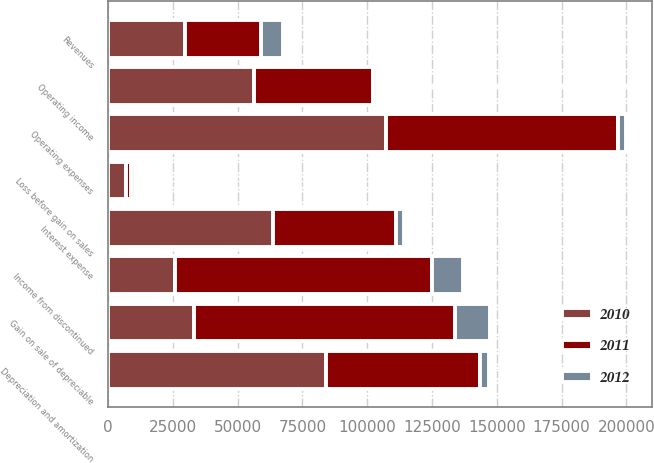<chart> <loc_0><loc_0><loc_500><loc_500><stacked_bar_chart><ecel><fcel>Revenues<fcel>Operating expenses<fcel>Depreciation and amortization<fcel>Operating income<fcel>Interest expense<fcel>Loss before gain on sales<fcel>Gain on sale of depreciable<fcel>Income from discontinued<nl><fcel>2012<fcel>8284<fcel>3286<fcel>3454<fcel>1544<fcel>3093<fcel>1549<fcel>13467<fcel>11918<nl><fcel>2011<fcel>29512.5<fcel>89123<fcel>59453<fcel>45590<fcel>47356<fcel>1766<fcel>100882<fcel>99116<nl><fcel>2010<fcel>29512.5<fcel>107412<fcel>84139<fcel>56473<fcel>63556<fcel>7083<fcel>33054<fcel>25971<nl></chart> 